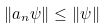Convert formula to latex. <formula><loc_0><loc_0><loc_500><loc_500>\| a _ { n } \psi \| \leq \| \psi \|</formula> 